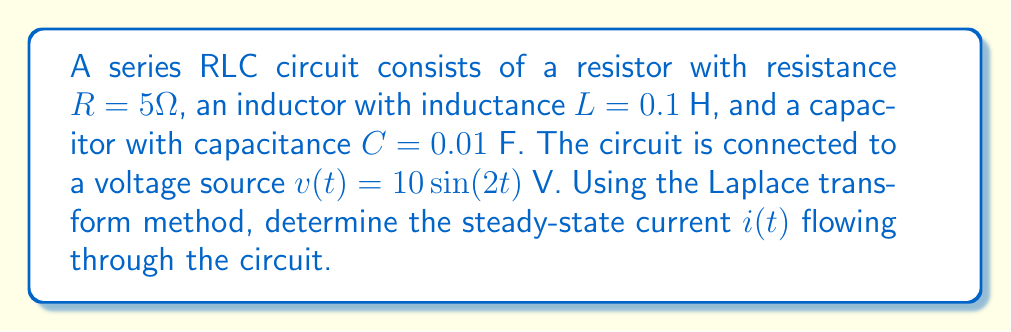Solve this math problem. Let's approach this problem step-by-step using the Laplace transform method:

1) First, we need to write the differential equation for the circuit:

   $$L\frac{d^2i}{dt^2} + R\frac{di}{dt} + \frac{1}{C}i = v(t)$$

2) Now, let's take the Laplace transform of both sides. Remember that the Laplace transform of $\sin(at)$ is $\frac{a}{s^2+a^2}$:

   $$L[L\frac{d^2i}{dt^2} + R\frac{di}{dt} + \frac{1}{C}i] = L[10\sin(2t)]$$

   $$Ls^2I(s) - Lsi(0) - Li'(0) + RsI(s) - Ri(0) + \frac{1}{C}I(s) = \frac{20}{s^2+4}$$

3) Assuming initial conditions are zero (i.e., $i(0) = 0$ and $i'(0) = 0$):

   $$I(s)(Ls^2 + Rs + \frac{1}{C}) = \frac{20}{s^2+4}$$

4) Substituting the given values:

   $$I(s)(0.1s^2 + 5s + 100) = \frac{20}{s^2+4}$$

5) Solving for $I(s)$:

   $$I(s) = \frac{20}{(0.1s^2 + 5s + 100)(s^2+4)}$$

6) To find the steady-state response, we only need to consider the terms with $s = \pm 2i$:

   $$I(s) \approx \frac{20}{(0.1(-4) + 5(2i) + 100)(4)}$$

7) Simplifying:

   $$I(s) \approx \frac{20}{(99.6 + 10i)(4)} = \frac{5}{99.6 + 10i}$$

8) Converting back to the time domain:

   $$i(t) = \frac{5}{\sqrt{99.6^2 + 10^2}}\sin(2t - \tan^{-1}(\frac{10}{99.6}))$$

9) Simplifying further:

   $$i(t) \approx 0.0499\sin(2t - 0.1003)$$
Answer: $i(t) \approx 0.0499\sin(2t - 0.1003)$ A 